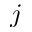<formula> <loc_0><loc_0><loc_500><loc_500>j</formula> 